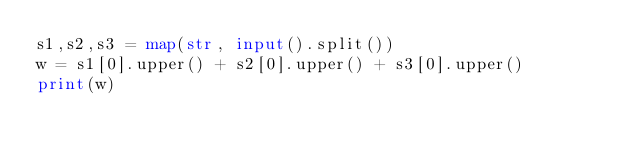Convert code to text. <code><loc_0><loc_0><loc_500><loc_500><_Python_>s1,s2,s3 = map(str, input().split())
w = s1[0].upper() + s2[0].upper() + s3[0].upper()
print(w)</code> 